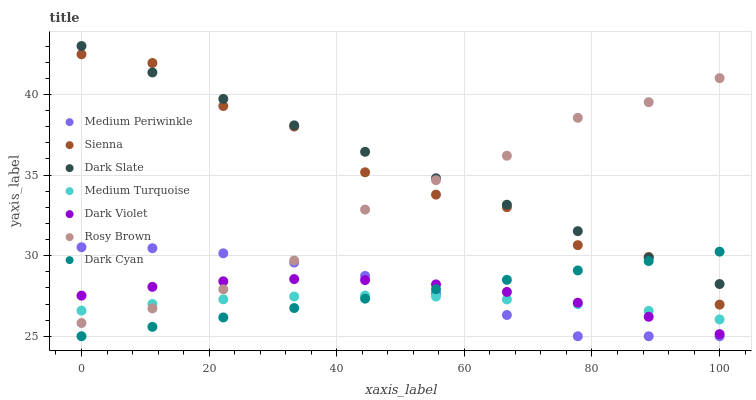Does Medium Turquoise have the minimum area under the curve?
Answer yes or no. Yes. Does Dark Slate have the maximum area under the curve?
Answer yes or no. Yes. Does Medium Periwinkle have the minimum area under the curve?
Answer yes or no. No. Does Medium Periwinkle have the maximum area under the curve?
Answer yes or no. No. Is Dark Cyan the smoothest?
Answer yes or no. Yes. Is Sienna the roughest?
Answer yes or no. Yes. Is Medium Periwinkle the smoothest?
Answer yes or no. No. Is Medium Periwinkle the roughest?
Answer yes or no. No. Does Medium Periwinkle have the lowest value?
Answer yes or no. Yes. Does Dark Violet have the lowest value?
Answer yes or no. No. Does Dark Slate have the highest value?
Answer yes or no. Yes. Does Medium Periwinkle have the highest value?
Answer yes or no. No. Is Dark Cyan less than Rosy Brown?
Answer yes or no. Yes. Is Sienna greater than Medium Turquoise?
Answer yes or no. Yes. Does Dark Cyan intersect Medium Periwinkle?
Answer yes or no. Yes. Is Dark Cyan less than Medium Periwinkle?
Answer yes or no. No. Is Dark Cyan greater than Medium Periwinkle?
Answer yes or no. No. Does Dark Cyan intersect Rosy Brown?
Answer yes or no. No. 